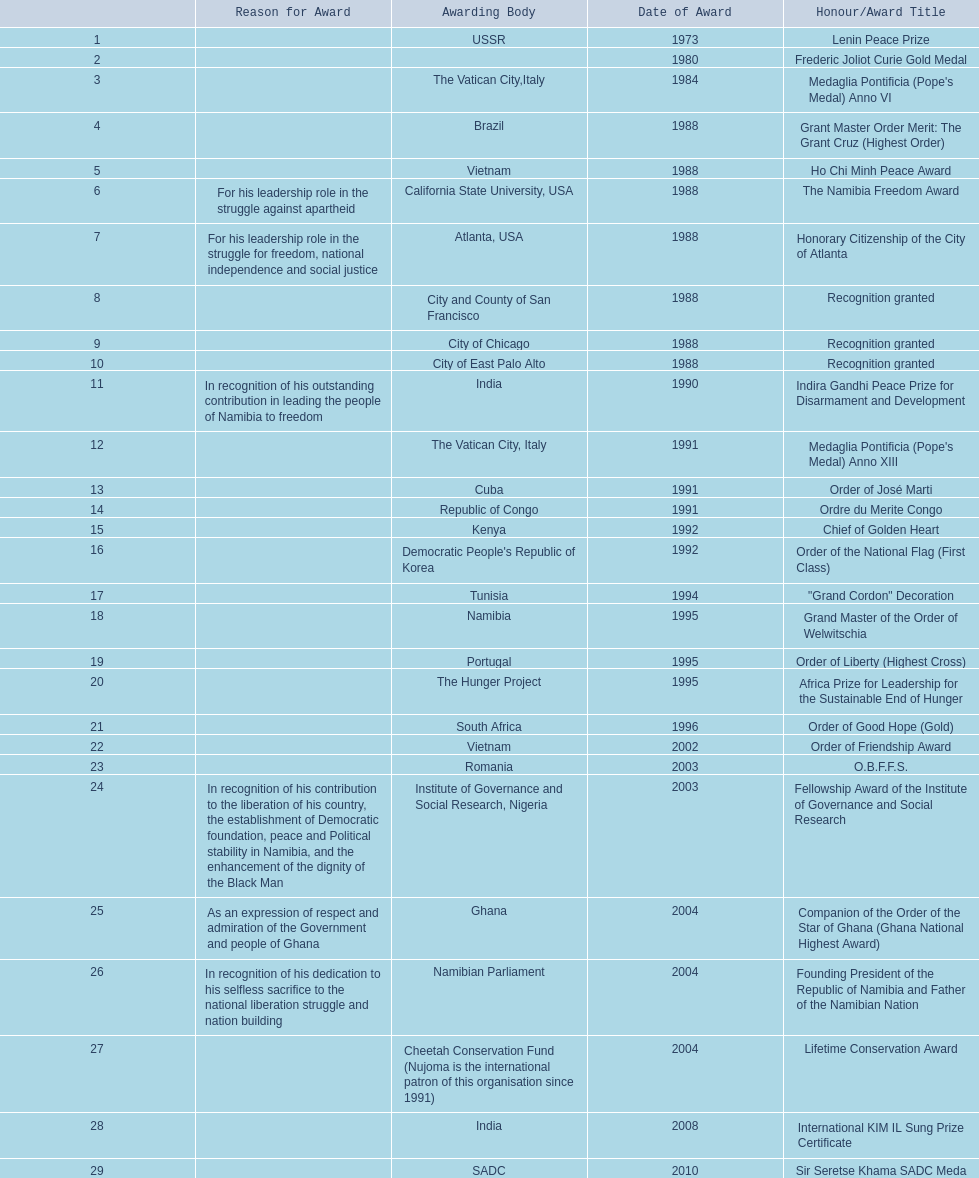What awards did sam nujoma win? 1, 1973, Lenin Peace Prize, Frederic Joliot Curie Gold Medal, Medaglia Pontificia (Pope's Medal) Anno VI, Grant Master Order Merit: The Grant Cruz (Highest Order), Ho Chi Minh Peace Award, The Namibia Freedom Award, Honorary Citizenship of the City of Atlanta, Recognition granted, Recognition granted, Recognition granted, Indira Gandhi Peace Prize for Disarmament and Development, Medaglia Pontificia (Pope's Medal) Anno XIII, Order of José Marti, Ordre du Merite Congo, Chief of Golden Heart, Order of the National Flag (First Class), "Grand Cordon" Decoration, Grand Master of the Order of Welwitschia, Order of Liberty (Highest Cross), Africa Prize for Leadership for the Sustainable End of Hunger, Order of Good Hope (Gold), Order of Friendship Award, O.B.F.F.S., Fellowship Award of the Institute of Governance and Social Research, Companion of the Order of the Star of Ghana (Ghana National Highest Award), Founding President of the Republic of Namibia and Father of the Namibian Nation, Lifetime Conservation Award, International KIM IL Sung Prize Certificate, Sir Seretse Khama SADC Meda. Who was the awarding body for the o.b.f.f.s award? Romania. 